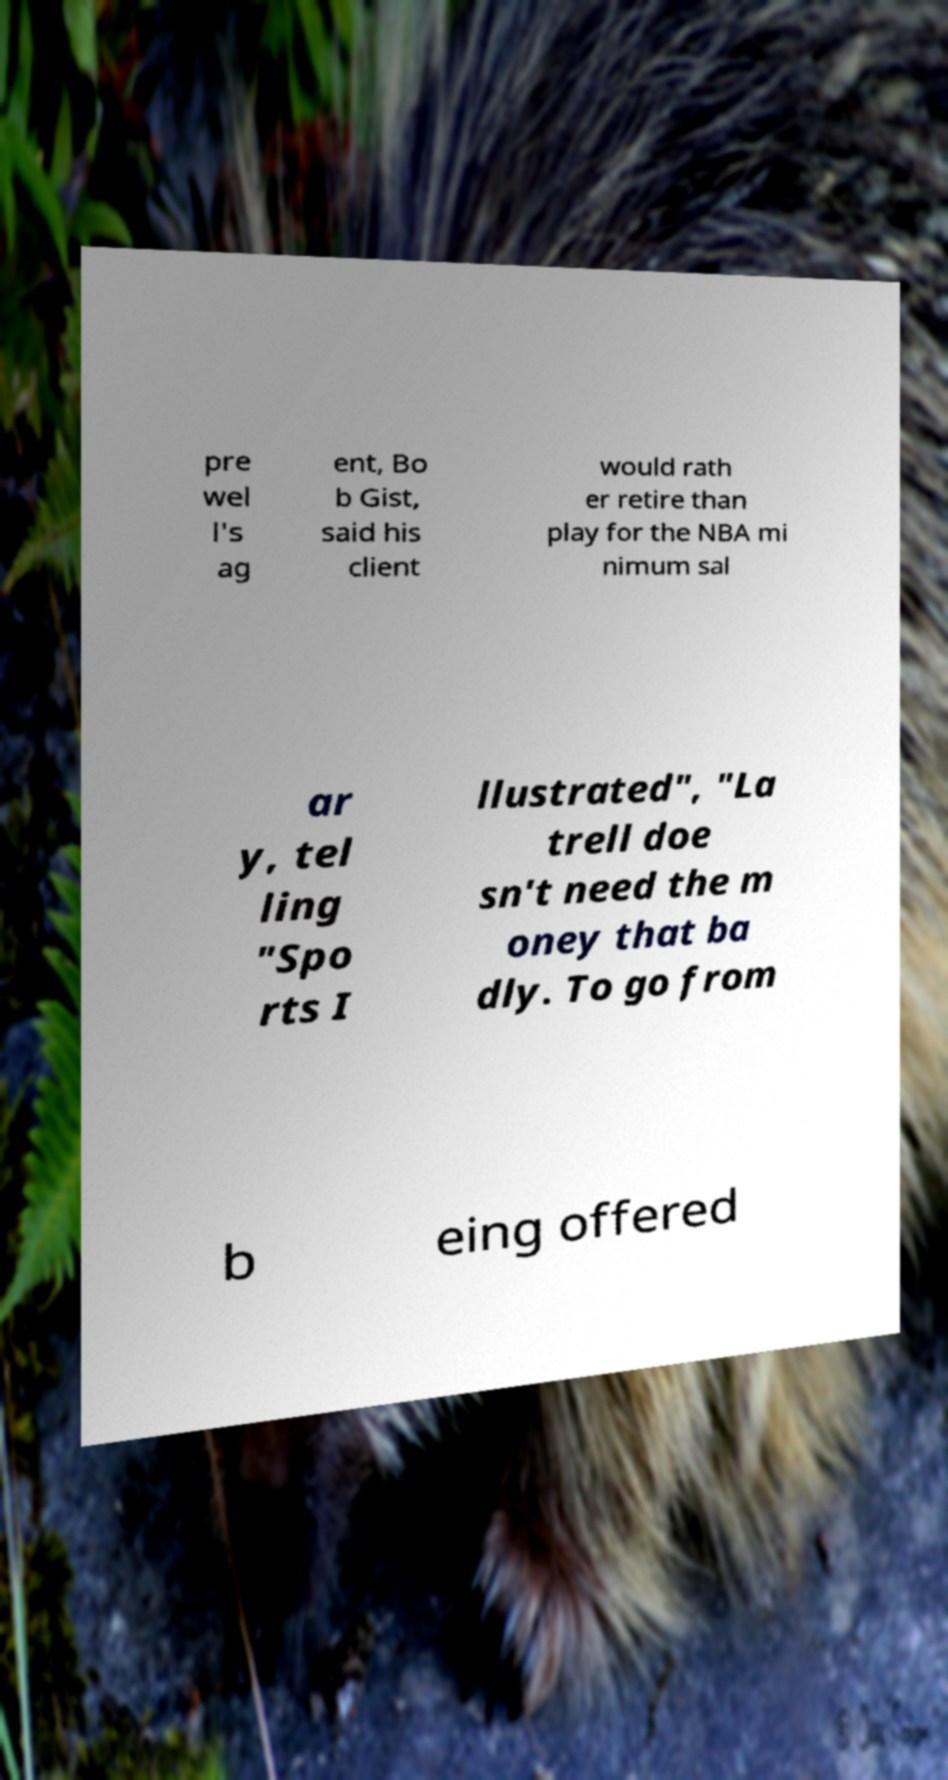For documentation purposes, I need the text within this image transcribed. Could you provide that? pre wel l's ag ent, Bo b Gist, said his client would rath er retire than play for the NBA mi nimum sal ar y, tel ling "Spo rts I llustrated", "La trell doe sn't need the m oney that ba dly. To go from b eing offered 